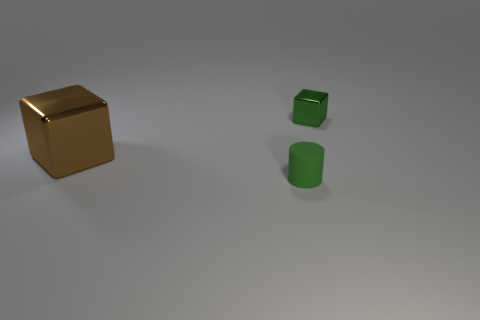How many big shiny objects have the same color as the matte object?
Provide a short and direct response. 0. There is another brown block that is the same material as the tiny block; what size is it?
Give a very brief answer. Large. What size is the green object in front of the metal cube that is on the left side of the tiny thing to the right of the small rubber cylinder?
Your response must be concise. Small. There is a thing in front of the large brown metal object; what size is it?
Provide a succinct answer. Small. What number of yellow objects are either big metal cubes or cylinders?
Your response must be concise. 0. Is there a yellow sphere of the same size as the brown metal block?
Your answer should be compact. No. What material is the green cylinder that is the same size as the green block?
Offer a terse response. Rubber. Is the size of the block that is behind the big brown thing the same as the cube that is to the left of the small green metallic object?
Give a very brief answer. No. How many things are either green blocks or large shiny objects that are left of the tiny metal object?
Give a very brief answer. 2. Is there another small metal thing of the same shape as the green shiny thing?
Give a very brief answer. No. 